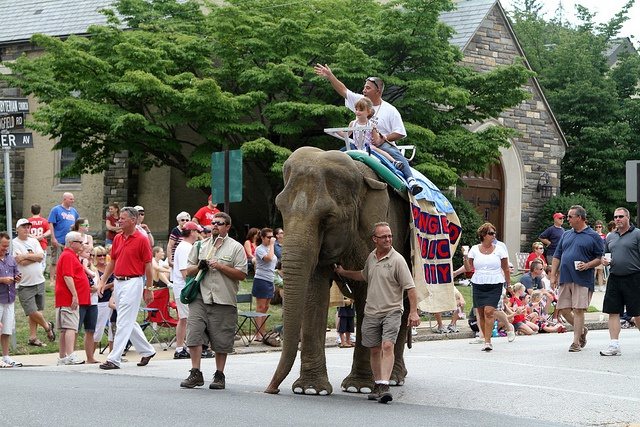Describe the objects in this image and their specific colors. I can see people in darkgray, lightgray, black, and brown tones, elephant in darkgray, black, and gray tones, people in darkgray, gray, black, and lightgray tones, people in darkgray, gray, and black tones, and people in darkgray, lavender, and brown tones in this image. 